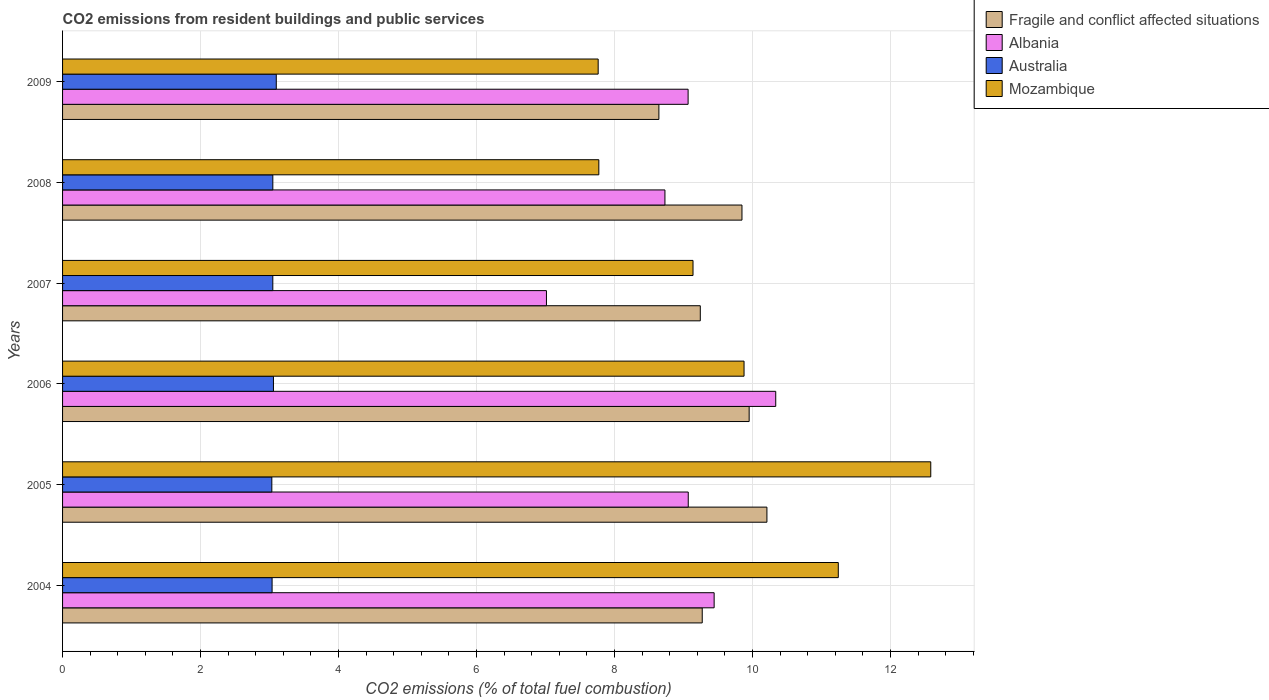How many groups of bars are there?
Keep it short and to the point. 6. How many bars are there on the 3rd tick from the top?
Offer a very short reply. 4. What is the total CO2 emitted in Fragile and conflict affected situations in 2009?
Provide a succinct answer. 8.64. Across all years, what is the maximum total CO2 emitted in Australia?
Your response must be concise. 3.1. Across all years, what is the minimum total CO2 emitted in Australia?
Offer a very short reply. 3.03. In which year was the total CO2 emitted in Mozambique maximum?
Offer a terse response. 2005. What is the total total CO2 emitted in Australia in the graph?
Give a very brief answer. 18.32. What is the difference between the total CO2 emitted in Mozambique in 2004 and that in 2005?
Provide a short and direct response. -1.34. What is the difference between the total CO2 emitted in Mozambique in 2004 and the total CO2 emitted in Fragile and conflict affected situations in 2007?
Ensure brevity in your answer.  2. What is the average total CO2 emitted in Fragile and conflict affected situations per year?
Your answer should be compact. 9.53. In the year 2008, what is the difference between the total CO2 emitted in Australia and total CO2 emitted in Fragile and conflict affected situations?
Provide a short and direct response. -6.8. What is the ratio of the total CO2 emitted in Albania in 2004 to that in 2005?
Offer a terse response. 1.04. Is the difference between the total CO2 emitted in Australia in 2008 and 2009 greater than the difference between the total CO2 emitted in Fragile and conflict affected situations in 2008 and 2009?
Provide a succinct answer. No. What is the difference between the highest and the second highest total CO2 emitted in Mozambique?
Offer a terse response. 1.34. What is the difference between the highest and the lowest total CO2 emitted in Australia?
Offer a terse response. 0.06. In how many years, is the total CO2 emitted in Mozambique greater than the average total CO2 emitted in Mozambique taken over all years?
Offer a very short reply. 3. Is the sum of the total CO2 emitted in Mozambique in 2004 and 2009 greater than the maximum total CO2 emitted in Australia across all years?
Provide a succinct answer. Yes. Is it the case that in every year, the sum of the total CO2 emitted in Albania and total CO2 emitted in Mozambique is greater than the sum of total CO2 emitted in Australia and total CO2 emitted in Fragile and conflict affected situations?
Your response must be concise. No. What does the 2nd bar from the top in 2004 represents?
Offer a terse response. Australia. Is it the case that in every year, the sum of the total CO2 emitted in Australia and total CO2 emitted in Mozambique is greater than the total CO2 emitted in Albania?
Offer a terse response. Yes. How many years are there in the graph?
Offer a terse response. 6. What is the difference between two consecutive major ticks on the X-axis?
Give a very brief answer. 2. Are the values on the major ticks of X-axis written in scientific E-notation?
Give a very brief answer. No. Does the graph contain any zero values?
Keep it short and to the point. No. Does the graph contain grids?
Offer a terse response. Yes. Where does the legend appear in the graph?
Provide a succinct answer. Top right. What is the title of the graph?
Provide a short and direct response. CO2 emissions from resident buildings and public services. Does "Iraq" appear as one of the legend labels in the graph?
Your response must be concise. No. What is the label or title of the X-axis?
Your answer should be very brief. CO2 emissions (% of total fuel combustion). What is the label or title of the Y-axis?
Keep it short and to the point. Years. What is the CO2 emissions (% of total fuel combustion) in Fragile and conflict affected situations in 2004?
Give a very brief answer. 9.27. What is the CO2 emissions (% of total fuel combustion) of Albania in 2004?
Make the answer very short. 9.44. What is the CO2 emissions (% of total fuel combustion) in Australia in 2004?
Ensure brevity in your answer.  3.04. What is the CO2 emissions (% of total fuel combustion) in Mozambique in 2004?
Your answer should be compact. 11.24. What is the CO2 emissions (% of total fuel combustion) in Fragile and conflict affected situations in 2005?
Ensure brevity in your answer.  10.21. What is the CO2 emissions (% of total fuel combustion) of Albania in 2005?
Give a very brief answer. 9.07. What is the CO2 emissions (% of total fuel combustion) in Australia in 2005?
Make the answer very short. 3.03. What is the CO2 emissions (% of total fuel combustion) of Mozambique in 2005?
Provide a succinct answer. 12.58. What is the CO2 emissions (% of total fuel combustion) in Fragile and conflict affected situations in 2006?
Offer a very short reply. 9.95. What is the CO2 emissions (% of total fuel combustion) of Albania in 2006?
Offer a very short reply. 10.34. What is the CO2 emissions (% of total fuel combustion) in Australia in 2006?
Your response must be concise. 3.06. What is the CO2 emissions (% of total fuel combustion) of Mozambique in 2006?
Your response must be concise. 9.88. What is the CO2 emissions (% of total fuel combustion) of Fragile and conflict affected situations in 2007?
Give a very brief answer. 9.24. What is the CO2 emissions (% of total fuel combustion) in Albania in 2007?
Your response must be concise. 7.01. What is the CO2 emissions (% of total fuel combustion) of Australia in 2007?
Give a very brief answer. 3.05. What is the CO2 emissions (% of total fuel combustion) of Mozambique in 2007?
Provide a short and direct response. 9.14. What is the CO2 emissions (% of total fuel combustion) of Fragile and conflict affected situations in 2008?
Provide a succinct answer. 9.85. What is the CO2 emissions (% of total fuel combustion) of Albania in 2008?
Keep it short and to the point. 8.73. What is the CO2 emissions (% of total fuel combustion) of Australia in 2008?
Provide a short and direct response. 3.05. What is the CO2 emissions (% of total fuel combustion) of Mozambique in 2008?
Your response must be concise. 7.77. What is the CO2 emissions (% of total fuel combustion) in Fragile and conflict affected situations in 2009?
Make the answer very short. 8.64. What is the CO2 emissions (% of total fuel combustion) of Albania in 2009?
Keep it short and to the point. 9.07. What is the CO2 emissions (% of total fuel combustion) of Australia in 2009?
Offer a terse response. 3.1. What is the CO2 emissions (% of total fuel combustion) of Mozambique in 2009?
Provide a succinct answer. 7.76. Across all years, what is the maximum CO2 emissions (% of total fuel combustion) of Fragile and conflict affected situations?
Make the answer very short. 10.21. Across all years, what is the maximum CO2 emissions (% of total fuel combustion) of Albania?
Give a very brief answer. 10.34. Across all years, what is the maximum CO2 emissions (% of total fuel combustion) of Australia?
Your answer should be compact. 3.1. Across all years, what is the maximum CO2 emissions (% of total fuel combustion) of Mozambique?
Provide a succinct answer. 12.58. Across all years, what is the minimum CO2 emissions (% of total fuel combustion) of Fragile and conflict affected situations?
Offer a terse response. 8.64. Across all years, what is the minimum CO2 emissions (% of total fuel combustion) of Albania?
Ensure brevity in your answer.  7.01. Across all years, what is the minimum CO2 emissions (% of total fuel combustion) in Australia?
Your answer should be compact. 3.03. Across all years, what is the minimum CO2 emissions (% of total fuel combustion) in Mozambique?
Your answer should be compact. 7.76. What is the total CO2 emissions (% of total fuel combustion) of Fragile and conflict affected situations in the graph?
Your answer should be very brief. 57.16. What is the total CO2 emissions (% of total fuel combustion) in Albania in the graph?
Your response must be concise. 53.66. What is the total CO2 emissions (% of total fuel combustion) in Australia in the graph?
Your answer should be compact. 18.32. What is the total CO2 emissions (% of total fuel combustion) of Mozambique in the graph?
Give a very brief answer. 58.37. What is the difference between the CO2 emissions (% of total fuel combustion) in Fragile and conflict affected situations in 2004 and that in 2005?
Your response must be concise. -0.94. What is the difference between the CO2 emissions (% of total fuel combustion) of Albania in 2004 and that in 2005?
Provide a short and direct response. 0.38. What is the difference between the CO2 emissions (% of total fuel combustion) in Australia in 2004 and that in 2005?
Provide a short and direct response. 0. What is the difference between the CO2 emissions (% of total fuel combustion) in Mozambique in 2004 and that in 2005?
Keep it short and to the point. -1.34. What is the difference between the CO2 emissions (% of total fuel combustion) of Fragile and conflict affected situations in 2004 and that in 2006?
Provide a short and direct response. -0.68. What is the difference between the CO2 emissions (% of total fuel combustion) of Albania in 2004 and that in 2006?
Give a very brief answer. -0.89. What is the difference between the CO2 emissions (% of total fuel combustion) of Australia in 2004 and that in 2006?
Give a very brief answer. -0.02. What is the difference between the CO2 emissions (% of total fuel combustion) of Mozambique in 2004 and that in 2006?
Offer a very short reply. 1.37. What is the difference between the CO2 emissions (% of total fuel combustion) in Fragile and conflict affected situations in 2004 and that in 2007?
Give a very brief answer. 0.03. What is the difference between the CO2 emissions (% of total fuel combustion) of Albania in 2004 and that in 2007?
Your answer should be compact. 2.43. What is the difference between the CO2 emissions (% of total fuel combustion) in Australia in 2004 and that in 2007?
Offer a very short reply. -0.01. What is the difference between the CO2 emissions (% of total fuel combustion) of Mozambique in 2004 and that in 2007?
Ensure brevity in your answer.  2.11. What is the difference between the CO2 emissions (% of total fuel combustion) in Fragile and conflict affected situations in 2004 and that in 2008?
Ensure brevity in your answer.  -0.58. What is the difference between the CO2 emissions (% of total fuel combustion) in Albania in 2004 and that in 2008?
Make the answer very short. 0.71. What is the difference between the CO2 emissions (% of total fuel combustion) of Australia in 2004 and that in 2008?
Offer a terse response. -0.01. What is the difference between the CO2 emissions (% of total fuel combustion) in Mozambique in 2004 and that in 2008?
Offer a terse response. 3.47. What is the difference between the CO2 emissions (% of total fuel combustion) in Fragile and conflict affected situations in 2004 and that in 2009?
Ensure brevity in your answer.  0.63. What is the difference between the CO2 emissions (% of total fuel combustion) in Albania in 2004 and that in 2009?
Provide a short and direct response. 0.38. What is the difference between the CO2 emissions (% of total fuel combustion) of Australia in 2004 and that in 2009?
Offer a very short reply. -0.06. What is the difference between the CO2 emissions (% of total fuel combustion) in Mozambique in 2004 and that in 2009?
Give a very brief answer. 3.48. What is the difference between the CO2 emissions (% of total fuel combustion) of Fragile and conflict affected situations in 2005 and that in 2006?
Provide a succinct answer. 0.26. What is the difference between the CO2 emissions (% of total fuel combustion) in Albania in 2005 and that in 2006?
Make the answer very short. -1.27. What is the difference between the CO2 emissions (% of total fuel combustion) in Australia in 2005 and that in 2006?
Provide a short and direct response. -0.02. What is the difference between the CO2 emissions (% of total fuel combustion) of Mozambique in 2005 and that in 2006?
Your answer should be very brief. 2.71. What is the difference between the CO2 emissions (% of total fuel combustion) in Fragile and conflict affected situations in 2005 and that in 2007?
Provide a short and direct response. 0.97. What is the difference between the CO2 emissions (% of total fuel combustion) in Albania in 2005 and that in 2007?
Keep it short and to the point. 2.06. What is the difference between the CO2 emissions (% of total fuel combustion) in Australia in 2005 and that in 2007?
Your response must be concise. -0.01. What is the difference between the CO2 emissions (% of total fuel combustion) in Mozambique in 2005 and that in 2007?
Your answer should be compact. 3.45. What is the difference between the CO2 emissions (% of total fuel combustion) of Fragile and conflict affected situations in 2005 and that in 2008?
Offer a terse response. 0.36. What is the difference between the CO2 emissions (% of total fuel combustion) of Albania in 2005 and that in 2008?
Offer a very short reply. 0.34. What is the difference between the CO2 emissions (% of total fuel combustion) in Australia in 2005 and that in 2008?
Your answer should be compact. -0.01. What is the difference between the CO2 emissions (% of total fuel combustion) in Mozambique in 2005 and that in 2008?
Your response must be concise. 4.81. What is the difference between the CO2 emissions (% of total fuel combustion) in Fragile and conflict affected situations in 2005 and that in 2009?
Offer a very short reply. 1.57. What is the difference between the CO2 emissions (% of total fuel combustion) of Albania in 2005 and that in 2009?
Offer a terse response. 0. What is the difference between the CO2 emissions (% of total fuel combustion) in Australia in 2005 and that in 2009?
Offer a very short reply. -0.06. What is the difference between the CO2 emissions (% of total fuel combustion) of Mozambique in 2005 and that in 2009?
Ensure brevity in your answer.  4.82. What is the difference between the CO2 emissions (% of total fuel combustion) in Fragile and conflict affected situations in 2006 and that in 2007?
Keep it short and to the point. 0.71. What is the difference between the CO2 emissions (% of total fuel combustion) of Albania in 2006 and that in 2007?
Offer a terse response. 3.32. What is the difference between the CO2 emissions (% of total fuel combustion) in Australia in 2006 and that in 2007?
Provide a succinct answer. 0.01. What is the difference between the CO2 emissions (% of total fuel combustion) in Mozambique in 2006 and that in 2007?
Keep it short and to the point. 0.74. What is the difference between the CO2 emissions (% of total fuel combustion) of Fragile and conflict affected situations in 2006 and that in 2008?
Keep it short and to the point. 0.1. What is the difference between the CO2 emissions (% of total fuel combustion) of Albania in 2006 and that in 2008?
Your answer should be compact. 1.61. What is the difference between the CO2 emissions (% of total fuel combustion) in Australia in 2006 and that in 2008?
Ensure brevity in your answer.  0.01. What is the difference between the CO2 emissions (% of total fuel combustion) of Mozambique in 2006 and that in 2008?
Make the answer very short. 2.1. What is the difference between the CO2 emissions (% of total fuel combustion) of Fragile and conflict affected situations in 2006 and that in 2009?
Offer a terse response. 1.31. What is the difference between the CO2 emissions (% of total fuel combustion) in Albania in 2006 and that in 2009?
Provide a short and direct response. 1.27. What is the difference between the CO2 emissions (% of total fuel combustion) of Australia in 2006 and that in 2009?
Your answer should be compact. -0.04. What is the difference between the CO2 emissions (% of total fuel combustion) in Mozambique in 2006 and that in 2009?
Offer a terse response. 2.11. What is the difference between the CO2 emissions (% of total fuel combustion) of Fragile and conflict affected situations in 2007 and that in 2008?
Your response must be concise. -0.6. What is the difference between the CO2 emissions (% of total fuel combustion) in Albania in 2007 and that in 2008?
Ensure brevity in your answer.  -1.72. What is the difference between the CO2 emissions (% of total fuel combustion) of Australia in 2007 and that in 2008?
Ensure brevity in your answer.  -0. What is the difference between the CO2 emissions (% of total fuel combustion) in Mozambique in 2007 and that in 2008?
Your answer should be very brief. 1.36. What is the difference between the CO2 emissions (% of total fuel combustion) of Albania in 2007 and that in 2009?
Your response must be concise. -2.05. What is the difference between the CO2 emissions (% of total fuel combustion) of Australia in 2007 and that in 2009?
Offer a very short reply. -0.05. What is the difference between the CO2 emissions (% of total fuel combustion) of Mozambique in 2007 and that in 2009?
Provide a succinct answer. 1.37. What is the difference between the CO2 emissions (% of total fuel combustion) of Fragile and conflict affected situations in 2008 and that in 2009?
Offer a very short reply. 1.2. What is the difference between the CO2 emissions (% of total fuel combustion) of Albania in 2008 and that in 2009?
Provide a short and direct response. -0.34. What is the difference between the CO2 emissions (% of total fuel combustion) of Mozambique in 2008 and that in 2009?
Offer a terse response. 0.01. What is the difference between the CO2 emissions (% of total fuel combustion) in Fragile and conflict affected situations in 2004 and the CO2 emissions (% of total fuel combustion) in Albania in 2005?
Give a very brief answer. 0.2. What is the difference between the CO2 emissions (% of total fuel combustion) of Fragile and conflict affected situations in 2004 and the CO2 emissions (% of total fuel combustion) of Australia in 2005?
Provide a succinct answer. 6.24. What is the difference between the CO2 emissions (% of total fuel combustion) of Fragile and conflict affected situations in 2004 and the CO2 emissions (% of total fuel combustion) of Mozambique in 2005?
Keep it short and to the point. -3.31. What is the difference between the CO2 emissions (% of total fuel combustion) in Albania in 2004 and the CO2 emissions (% of total fuel combustion) in Australia in 2005?
Your answer should be very brief. 6.41. What is the difference between the CO2 emissions (% of total fuel combustion) of Albania in 2004 and the CO2 emissions (% of total fuel combustion) of Mozambique in 2005?
Give a very brief answer. -3.14. What is the difference between the CO2 emissions (% of total fuel combustion) in Australia in 2004 and the CO2 emissions (% of total fuel combustion) in Mozambique in 2005?
Provide a short and direct response. -9.55. What is the difference between the CO2 emissions (% of total fuel combustion) of Fragile and conflict affected situations in 2004 and the CO2 emissions (% of total fuel combustion) of Albania in 2006?
Offer a terse response. -1.07. What is the difference between the CO2 emissions (% of total fuel combustion) in Fragile and conflict affected situations in 2004 and the CO2 emissions (% of total fuel combustion) in Australia in 2006?
Provide a short and direct response. 6.21. What is the difference between the CO2 emissions (% of total fuel combustion) in Fragile and conflict affected situations in 2004 and the CO2 emissions (% of total fuel combustion) in Mozambique in 2006?
Your answer should be compact. -0.61. What is the difference between the CO2 emissions (% of total fuel combustion) of Albania in 2004 and the CO2 emissions (% of total fuel combustion) of Australia in 2006?
Provide a succinct answer. 6.39. What is the difference between the CO2 emissions (% of total fuel combustion) in Albania in 2004 and the CO2 emissions (% of total fuel combustion) in Mozambique in 2006?
Make the answer very short. -0.43. What is the difference between the CO2 emissions (% of total fuel combustion) of Australia in 2004 and the CO2 emissions (% of total fuel combustion) of Mozambique in 2006?
Keep it short and to the point. -6.84. What is the difference between the CO2 emissions (% of total fuel combustion) of Fragile and conflict affected situations in 2004 and the CO2 emissions (% of total fuel combustion) of Albania in 2007?
Provide a short and direct response. 2.26. What is the difference between the CO2 emissions (% of total fuel combustion) in Fragile and conflict affected situations in 2004 and the CO2 emissions (% of total fuel combustion) in Australia in 2007?
Your answer should be compact. 6.22. What is the difference between the CO2 emissions (% of total fuel combustion) in Fragile and conflict affected situations in 2004 and the CO2 emissions (% of total fuel combustion) in Mozambique in 2007?
Make the answer very short. 0.13. What is the difference between the CO2 emissions (% of total fuel combustion) of Albania in 2004 and the CO2 emissions (% of total fuel combustion) of Australia in 2007?
Offer a terse response. 6.4. What is the difference between the CO2 emissions (% of total fuel combustion) of Albania in 2004 and the CO2 emissions (% of total fuel combustion) of Mozambique in 2007?
Make the answer very short. 0.31. What is the difference between the CO2 emissions (% of total fuel combustion) of Australia in 2004 and the CO2 emissions (% of total fuel combustion) of Mozambique in 2007?
Give a very brief answer. -6.1. What is the difference between the CO2 emissions (% of total fuel combustion) in Fragile and conflict affected situations in 2004 and the CO2 emissions (% of total fuel combustion) in Albania in 2008?
Your answer should be very brief. 0.54. What is the difference between the CO2 emissions (% of total fuel combustion) in Fragile and conflict affected situations in 2004 and the CO2 emissions (% of total fuel combustion) in Australia in 2008?
Provide a short and direct response. 6.22. What is the difference between the CO2 emissions (% of total fuel combustion) in Fragile and conflict affected situations in 2004 and the CO2 emissions (% of total fuel combustion) in Mozambique in 2008?
Give a very brief answer. 1.5. What is the difference between the CO2 emissions (% of total fuel combustion) of Albania in 2004 and the CO2 emissions (% of total fuel combustion) of Australia in 2008?
Provide a succinct answer. 6.4. What is the difference between the CO2 emissions (% of total fuel combustion) in Albania in 2004 and the CO2 emissions (% of total fuel combustion) in Mozambique in 2008?
Make the answer very short. 1.67. What is the difference between the CO2 emissions (% of total fuel combustion) of Australia in 2004 and the CO2 emissions (% of total fuel combustion) of Mozambique in 2008?
Provide a succinct answer. -4.74. What is the difference between the CO2 emissions (% of total fuel combustion) in Fragile and conflict affected situations in 2004 and the CO2 emissions (% of total fuel combustion) in Albania in 2009?
Your answer should be compact. 0.2. What is the difference between the CO2 emissions (% of total fuel combustion) of Fragile and conflict affected situations in 2004 and the CO2 emissions (% of total fuel combustion) of Australia in 2009?
Make the answer very short. 6.17. What is the difference between the CO2 emissions (% of total fuel combustion) in Fragile and conflict affected situations in 2004 and the CO2 emissions (% of total fuel combustion) in Mozambique in 2009?
Give a very brief answer. 1.51. What is the difference between the CO2 emissions (% of total fuel combustion) in Albania in 2004 and the CO2 emissions (% of total fuel combustion) in Australia in 2009?
Make the answer very short. 6.35. What is the difference between the CO2 emissions (% of total fuel combustion) of Albania in 2004 and the CO2 emissions (% of total fuel combustion) of Mozambique in 2009?
Ensure brevity in your answer.  1.68. What is the difference between the CO2 emissions (% of total fuel combustion) in Australia in 2004 and the CO2 emissions (% of total fuel combustion) in Mozambique in 2009?
Offer a very short reply. -4.73. What is the difference between the CO2 emissions (% of total fuel combustion) of Fragile and conflict affected situations in 2005 and the CO2 emissions (% of total fuel combustion) of Albania in 2006?
Offer a terse response. -0.13. What is the difference between the CO2 emissions (% of total fuel combustion) of Fragile and conflict affected situations in 2005 and the CO2 emissions (% of total fuel combustion) of Australia in 2006?
Offer a terse response. 7.15. What is the difference between the CO2 emissions (% of total fuel combustion) of Fragile and conflict affected situations in 2005 and the CO2 emissions (% of total fuel combustion) of Mozambique in 2006?
Offer a terse response. 0.33. What is the difference between the CO2 emissions (% of total fuel combustion) in Albania in 2005 and the CO2 emissions (% of total fuel combustion) in Australia in 2006?
Your answer should be very brief. 6.01. What is the difference between the CO2 emissions (% of total fuel combustion) of Albania in 2005 and the CO2 emissions (% of total fuel combustion) of Mozambique in 2006?
Provide a short and direct response. -0.81. What is the difference between the CO2 emissions (% of total fuel combustion) in Australia in 2005 and the CO2 emissions (% of total fuel combustion) in Mozambique in 2006?
Your response must be concise. -6.84. What is the difference between the CO2 emissions (% of total fuel combustion) in Fragile and conflict affected situations in 2005 and the CO2 emissions (% of total fuel combustion) in Albania in 2007?
Ensure brevity in your answer.  3.2. What is the difference between the CO2 emissions (% of total fuel combustion) of Fragile and conflict affected situations in 2005 and the CO2 emissions (% of total fuel combustion) of Australia in 2007?
Offer a terse response. 7.16. What is the difference between the CO2 emissions (% of total fuel combustion) of Fragile and conflict affected situations in 2005 and the CO2 emissions (% of total fuel combustion) of Mozambique in 2007?
Your answer should be compact. 1.07. What is the difference between the CO2 emissions (% of total fuel combustion) in Albania in 2005 and the CO2 emissions (% of total fuel combustion) in Australia in 2007?
Ensure brevity in your answer.  6.02. What is the difference between the CO2 emissions (% of total fuel combustion) of Albania in 2005 and the CO2 emissions (% of total fuel combustion) of Mozambique in 2007?
Ensure brevity in your answer.  -0.07. What is the difference between the CO2 emissions (% of total fuel combustion) in Australia in 2005 and the CO2 emissions (% of total fuel combustion) in Mozambique in 2007?
Your answer should be compact. -6.1. What is the difference between the CO2 emissions (% of total fuel combustion) of Fragile and conflict affected situations in 2005 and the CO2 emissions (% of total fuel combustion) of Albania in 2008?
Keep it short and to the point. 1.48. What is the difference between the CO2 emissions (% of total fuel combustion) of Fragile and conflict affected situations in 2005 and the CO2 emissions (% of total fuel combustion) of Australia in 2008?
Your answer should be compact. 7.16. What is the difference between the CO2 emissions (% of total fuel combustion) in Fragile and conflict affected situations in 2005 and the CO2 emissions (% of total fuel combustion) in Mozambique in 2008?
Your answer should be very brief. 2.44. What is the difference between the CO2 emissions (% of total fuel combustion) of Albania in 2005 and the CO2 emissions (% of total fuel combustion) of Australia in 2008?
Your answer should be compact. 6.02. What is the difference between the CO2 emissions (% of total fuel combustion) of Albania in 2005 and the CO2 emissions (% of total fuel combustion) of Mozambique in 2008?
Make the answer very short. 1.3. What is the difference between the CO2 emissions (% of total fuel combustion) of Australia in 2005 and the CO2 emissions (% of total fuel combustion) of Mozambique in 2008?
Provide a short and direct response. -4.74. What is the difference between the CO2 emissions (% of total fuel combustion) of Fragile and conflict affected situations in 2005 and the CO2 emissions (% of total fuel combustion) of Albania in 2009?
Provide a short and direct response. 1.14. What is the difference between the CO2 emissions (% of total fuel combustion) of Fragile and conflict affected situations in 2005 and the CO2 emissions (% of total fuel combustion) of Australia in 2009?
Your response must be concise. 7.11. What is the difference between the CO2 emissions (% of total fuel combustion) in Fragile and conflict affected situations in 2005 and the CO2 emissions (% of total fuel combustion) in Mozambique in 2009?
Make the answer very short. 2.45. What is the difference between the CO2 emissions (% of total fuel combustion) of Albania in 2005 and the CO2 emissions (% of total fuel combustion) of Australia in 2009?
Give a very brief answer. 5.97. What is the difference between the CO2 emissions (% of total fuel combustion) in Albania in 2005 and the CO2 emissions (% of total fuel combustion) in Mozambique in 2009?
Give a very brief answer. 1.31. What is the difference between the CO2 emissions (% of total fuel combustion) in Australia in 2005 and the CO2 emissions (% of total fuel combustion) in Mozambique in 2009?
Offer a terse response. -4.73. What is the difference between the CO2 emissions (% of total fuel combustion) of Fragile and conflict affected situations in 2006 and the CO2 emissions (% of total fuel combustion) of Albania in 2007?
Give a very brief answer. 2.94. What is the difference between the CO2 emissions (% of total fuel combustion) of Fragile and conflict affected situations in 2006 and the CO2 emissions (% of total fuel combustion) of Australia in 2007?
Your answer should be compact. 6.9. What is the difference between the CO2 emissions (% of total fuel combustion) in Fragile and conflict affected situations in 2006 and the CO2 emissions (% of total fuel combustion) in Mozambique in 2007?
Offer a very short reply. 0.81. What is the difference between the CO2 emissions (% of total fuel combustion) in Albania in 2006 and the CO2 emissions (% of total fuel combustion) in Australia in 2007?
Keep it short and to the point. 7.29. What is the difference between the CO2 emissions (% of total fuel combustion) of Albania in 2006 and the CO2 emissions (% of total fuel combustion) of Mozambique in 2007?
Keep it short and to the point. 1.2. What is the difference between the CO2 emissions (% of total fuel combustion) of Australia in 2006 and the CO2 emissions (% of total fuel combustion) of Mozambique in 2007?
Make the answer very short. -6.08. What is the difference between the CO2 emissions (% of total fuel combustion) in Fragile and conflict affected situations in 2006 and the CO2 emissions (% of total fuel combustion) in Albania in 2008?
Ensure brevity in your answer.  1.22. What is the difference between the CO2 emissions (% of total fuel combustion) of Fragile and conflict affected situations in 2006 and the CO2 emissions (% of total fuel combustion) of Australia in 2008?
Make the answer very short. 6.9. What is the difference between the CO2 emissions (% of total fuel combustion) of Fragile and conflict affected situations in 2006 and the CO2 emissions (% of total fuel combustion) of Mozambique in 2008?
Offer a very short reply. 2.18. What is the difference between the CO2 emissions (% of total fuel combustion) in Albania in 2006 and the CO2 emissions (% of total fuel combustion) in Australia in 2008?
Keep it short and to the point. 7.29. What is the difference between the CO2 emissions (% of total fuel combustion) in Albania in 2006 and the CO2 emissions (% of total fuel combustion) in Mozambique in 2008?
Keep it short and to the point. 2.56. What is the difference between the CO2 emissions (% of total fuel combustion) of Australia in 2006 and the CO2 emissions (% of total fuel combustion) of Mozambique in 2008?
Provide a succinct answer. -4.72. What is the difference between the CO2 emissions (% of total fuel combustion) in Fragile and conflict affected situations in 2006 and the CO2 emissions (% of total fuel combustion) in Albania in 2009?
Provide a succinct answer. 0.88. What is the difference between the CO2 emissions (% of total fuel combustion) of Fragile and conflict affected situations in 2006 and the CO2 emissions (% of total fuel combustion) of Australia in 2009?
Your response must be concise. 6.85. What is the difference between the CO2 emissions (% of total fuel combustion) in Fragile and conflict affected situations in 2006 and the CO2 emissions (% of total fuel combustion) in Mozambique in 2009?
Give a very brief answer. 2.19. What is the difference between the CO2 emissions (% of total fuel combustion) in Albania in 2006 and the CO2 emissions (% of total fuel combustion) in Australia in 2009?
Provide a short and direct response. 7.24. What is the difference between the CO2 emissions (% of total fuel combustion) of Albania in 2006 and the CO2 emissions (% of total fuel combustion) of Mozambique in 2009?
Your answer should be very brief. 2.57. What is the difference between the CO2 emissions (% of total fuel combustion) in Australia in 2006 and the CO2 emissions (% of total fuel combustion) in Mozambique in 2009?
Your answer should be very brief. -4.71. What is the difference between the CO2 emissions (% of total fuel combustion) in Fragile and conflict affected situations in 2007 and the CO2 emissions (% of total fuel combustion) in Albania in 2008?
Provide a short and direct response. 0.51. What is the difference between the CO2 emissions (% of total fuel combustion) of Fragile and conflict affected situations in 2007 and the CO2 emissions (% of total fuel combustion) of Australia in 2008?
Your answer should be compact. 6.2. What is the difference between the CO2 emissions (% of total fuel combustion) in Fragile and conflict affected situations in 2007 and the CO2 emissions (% of total fuel combustion) in Mozambique in 2008?
Provide a succinct answer. 1.47. What is the difference between the CO2 emissions (% of total fuel combustion) in Albania in 2007 and the CO2 emissions (% of total fuel combustion) in Australia in 2008?
Make the answer very short. 3.97. What is the difference between the CO2 emissions (% of total fuel combustion) of Albania in 2007 and the CO2 emissions (% of total fuel combustion) of Mozambique in 2008?
Your answer should be compact. -0.76. What is the difference between the CO2 emissions (% of total fuel combustion) of Australia in 2007 and the CO2 emissions (% of total fuel combustion) of Mozambique in 2008?
Your answer should be very brief. -4.72. What is the difference between the CO2 emissions (% of total fuel combustion) in Fragile and conflict affected situations in 2007 and the CO2 emissions (% of total fuel combustion) in Albania in 2009?
Provide a short and direct response. 0.18. What is the difference between the CO2 emissions (% of total fuel combustion) in Fragile and conflict affected situations in 2007 and the CO2 emissions (% of total fuel combustion) in Australia in 2009?
Make the answer very short. 6.15. What is the difference between the CO2 emissions (% of total fuel combustion) in Fragile and conflict affected situations in 2007 and the CO2 emissions (% of total fuel combustion) in Mozambique in 2009?
Offer a very short reply. 1.48. What is the difference between the CO2 emissions (% of total fuel combustion) of Albania in 2007 and the CO2 emissions (% of total fuel combustion) of Australia in 2009?
Offer a terse response. 3.92. What is the difference between the CO2 emissions (% of total fuel combustion) in Albania in 2007 and the CO2 emissions (% of total fuel combustion) in Mozambique in 2009?
Your answer should be very brief. -0.75. What is the difference between the CO2 emissions (% of total fuel combustion) in Australia in 2007 and the CO2 emissions (% of total fuel combustion) in Mozambique in 2009?
Ensure brevity in your answer.  -4.72. What is the difference between the CO2 emissions (% of total fuel combustion) in Fragile and conflict affected situations in 2008 and the CO2 emissions (% of total fuel combustion) in Albania in 2009?
Give a very brief answer. 0.78. What is the difference between the CO2 emissions (% of total fuel combustion) of Fragile and conflict affected situations in 2008 and the CO2 emissions (% of total fuel combustion) of Australia in 2009?
Make the answer very short. 6.75. What is the difference between the CO2 emissions (% of total fuel combustion) in Fragile and conflict affected situations in 2008 and the CO2 emissions (% of total fuel combustion) in Mozambique in 2009?
Keep it short and to the point. 2.08. What is the difference between the CO2 emissions (% of total fuel combustion) in Albania in 2008 and the CO2 emissions (% of total fuel combustion) in Australia in 2009?
Ensure brevity in your answer.  5.63. What is the difference between the CO2 emissions (% of total fuel combustion) in Albania in 2008 and the CO2 emissions (% of total fuel combustion) in Mozambique in 2009?
Your response must be concise. 0.97. What is the difference between the CO2 emissions (% of total fuel combustion) of Australia in 2008 and the CO2 emissions (% of total fuel combustion) of Mozambique in 2009?
Keep it short and to the point. -4.72. What is the average CO2 emissions (% of total fuel combustion) of Fragile and conflict affected situations per year?
Your response must be concise. 9.53. What is the average CO2 emissions (% of total fuel combustion) in Albania per year?
Offer a very short reply. 8.94. What is the average CO2 emissions (% of total fuel combustion) of Australia per year?
Make the answer very short. 3.05. What is the average CO2 emissions (% of total fuel combustion) in Mozambique per year?
Your answer should be compact. 9.73. In the year 2004, what is the difference between the CO2 emissions (% of total fuel combustion) in Fragile and conflict affected situations and CO2 emissions (% of total fuel combustion) in Albania?
Make the answer very short. -0.17. In the year 2004, what is the difference between the CO2 emissions (% of total fuel combustion) in Fragile and conflict affected situations and CO2 emissions (% of total fuel combustion) in Australia?
Your answer should be very brief. 6.23. In the year 2004, what is the difference between the CO2 emissions (% of total fuel combustion) of Fragile and conflict affected situations and CO2 emissions (% of total fuel combustion) of Mozambique?
Provide a succinct answer. -1.97. In the year 2004, what is the difference between the CO2 emissions (% of total fuel combustion) of Albania and CO2 emissions (% of total fuel combustion) of Australia?
Your response must be concise. 6.41. In the year 2004, what is the difference between the CO2 emissions (% of total fuel combustion) in Albania and CO2 emissions (% of total fuel combustion) in Mozambique?
Ensure brevity in your answer.  -1.8. In the year 2004, what is the difference between the CO2 emissions (% of total fuel combustion) of Australia and CO2 emissions (% of total fuel combustion) of Mozambique?
Give a very brief answer. -8.21. In the year 2005, what is the difference between the CO2 emissions (% of total fuel combustion) in Fragile and conflict affected situations and CO2 emissions (% of total fuel combustion) in Albania?
Offer a terse response. 1.14. In the year 2005, what is the difference between the CO2 emissions (% of total fuel combustion) of Fragile and conflict affected situations and CO2 emissions (% of total fuel combustion) of Australia?
Ensure brevity in your answer.  7.18. In the year 2005, what is the difference between the CO2 emissions (% of total fuel combustion) in Fragile and conflict affected situations and CO2 emissions (% of total fuel combustion) in Mozambique?
Provide a succinct answer. -2.37. In the year 2005, what is the difference between the CO2 emissions (% of total fuel combustion) in Albania and CO2 emissions (% of total fuel combustion) in Australia?
Ensure brevity in your answer.  6.04. In the year 2005, what is the difference between the CO2 emissions (% of total fuel combustion) of Albania and CO2 emissions (% of total fuel combustion) of Mozambique?
Keep it short and to the point. -3.51. In the year 2005, what is the difference between the CO2 emissions (% of total fuel combustion) in Australia and CO2 emissions (% of total fuel combustion) in Mozambique?
Make the answer very short. -9.55. In the year 2006, what is the difference between the CO2 emissions (% of total fuel combustion) in Fragile and conflict affected situations and CO2 emissions (% of total fuel combustion) in Albania?
Your answer should be very brief. -0.39. In the year 2006, what is the difference between the CO2 emissions (% of total fuel combustion) of Fragile and conflict affected situations and CO2 emissions (% of total fuel combustion) of Australia?
Your answer should be compact. 6.89. In the year 2006, what is the difference between the CO2 emissions (% of total fuel combustion) of Fragile and conflict affected situations and CO2 emissions (% of total fuel combustion) of Mozambique?
Your response must be concise. 0.07. In the year 2006, what is the difference between the CO2 emissions (% of total fuel combustion) in Albania and CO2 emissions (% of total fuel combustion) in Australia?
Keep it short and to the point. 7.28. In the year 2006, what is the difference between the CO2 emissions (% of total fuel combustion) of Albania and CO2 emissions (% of total fuel combustion) of Mozambique?
Your response must be concise. 0.46. In the year 2006, what is the difference between the CO2 emissions (% of total fuel combustion) of Australia and CO2 emissions (% of total fuel combustion) of Mozambique?
Your response must be concise. -6.82. In the year 2007, what is the difference between the CO2 emissions (% of total fuel combustion) in Fragile and conflict affected situations and CO2 emissions (% of total fuel combustion) in Albania?
Your answer should be very brief. 2.23. In the year 2007, what is the difference between the CO2 emissions (% of total fuel combustion) of Fragile and conflict affected situations and CO2 emissions (% of total fuel combustion) of Australia?
Your answer should be very brief. 6.2. In the year 2007, what is the difference between the CO2 emissions (% of total fuel combustion) in Fragile and conflict affected situations and CO2 emissions (% of total fuel combustion) in Mozambique?
Provide a short and direct response. 0.11. In the year 2007, what is the difference between the CO2 emissions (% of total fuel combustion) of Albania and CO2 emissions (% of total fuel combustion) of Australia?
Keep it short and to the point. 3.97. In the year 2007, what is the difference between the CO2 emissions (% of total fuel combustion) of Albania and CO2 emissions (% of total fuel combustion) of Mozambique?
Your response must be concise. -2.12. In the year 2007, what is the difference between the CO2 emissions (% of total fuel combustion) in Australia and CO2 emissions (% of total fuel combustion) in Mozambique?
Your answer should be compact. -6.09. In the year 2008, what is the difference between the CO2 emissions (% of total fuel combustion) of Fragile and conflict affected situations and CO2 emissions (% of total fuel combustion) of Albania?
Make the answer very short. 1.12. In the year 2008, what is the difference between the CO2 emissions (% of total fuel combustion) in Fragile and conflict affected situations and CO2 emissions (% of total fuel combustion) in Australia?
Offer a terse response. 6.8. In the year 2008, what is the difference between the CO2 emissions (% of total fuel combustion) in Fragile and conflict affected situations and CO2 emissions (% of total fuel combustion) in Mozambique?
Keep it short and to the point. 2.07. In the year 2008, what is the difference between the CO2 emissions (% of total fuel combustion) of Albania and CO2 emissions (% of total fuel combustion) of Australia?
Provide a succinct answer. 5.68. In the year 2008, what is the difference between the CO2 emissions (% of total fuel combustion) in Albania and CO2 emissions (% of total fuel combustion) in Mozambique?
Keep it short and to the point. 0.96. In the year 2008, what is the difference between the CO2 emissions (% of total fuel combustion) of Australia and CO2 emissions (% of total fuel combustion) of Mozambique?
Make the answer very short. -4.72. In the year 2009, what is the difference between the CO2 emissions (% of total fuel combustion) of Fragile and conflict affected situations and CO2 emissions (% of total fuel combustion) of Albania?
Keep it short and to the point. -0.42. In the year 2009, what is the difference between the CO2 emissions (% of total fuel combustion) of Fragile and conflict affected situations and CO2 emissions (% of total fuel combustion) of Australia?
Your answer should be compact. 5.55. In the year 2009, what is the difference between the CO2 emissions (% of total fuel combustion) in Fragile and conflict affected situations and CO2 emissions (% of total fuel combustion) in Mozambique?
Provide a succinct answer. 0.88. In the year 2009, what is the difference between the CO2 emissions (% of total fuel combustion) in Albania and CO2 emissions (% of total fuel combustion) in Australia?
Your answer should be very brief. 5.97. In the year 2009, what is the difference between the CO2 emissions (% of total fuel combustion) in Albania and CO2 emissions (% of total fuel combustion) in Mozambique?
Provide a succinct answer. 1.3. In the year 2009, what is the difference between the CO2 emissions (% of total fuel combustion) of Australia and CO2 emissions (% of total fuel combustion) of Mozambique?
Offer a terse response. -4.67. What is the ratio of the CO2 emissions (% of total fuel combustion) in Fragile and conflict affected situations in 2004 to that in 2005?
Your answer should be very brief. 0.91. What is the ratio of the CO2 emissions (% of total fuel combustion) of Albania in 2004 to that in 2005?
Offer a very short reply. 1.04. What is the ratio of the CO2 emissions (% of total fuel combustion) of Mozambique in 2004 to that in 2005?
Ensure brevity in your answer.  0.89. What is the ratio of the CO2 emissions (% of total fuel combustion) of Fragile and conflict affected situations in 2004 to that in 2006?
Your response must be concise. 0.93. What is the ratio of the CO2 emissions (% of total fuel combustion) in Albania in 2004 to that in 2006?
Your answer should be very brief. 0.91. What is the ratio of the CO2 emissions (% of total fuel combustion) of Australia in 2004 to that in 2006?
Offer a very short reply. 0.99. What is the ratio of the CO2 emissions (% of total fuel combustion) of Mozambique in 2004 to that in 2006?
Offer a terse response. 1.14. What is the ratio of the CO2 emissions (% of total fuel combustion) of Fragile and conflict affected situations in 2004 to that in 2007?
Make the answer very short. 1. What is the ratio of the CO2 emissions (% of total fuel combustion) in Albania in 2004 to that in 2007?
Give a very brief answer. 1.35. What is the ratio of the CO2 emissions (% of total fuel combustion) of Mozambique in 2004 to that in 2007?
Offer a terse response. 1.23. What is the ratio of the CO2 emissions (% of total fuel combustion) in Fragile and conflict affected situations in 2004 to that in 2008?
Ensure brevity in your answer.  0.94. What is the ratio of the CO2 emissions (% of total fuel combustion) in Albania in 2004 to that in 2008?
Your answer should be compact. 1.08. What is the ratio of the CO2 emissions (% of total fuel combustion) in Australia in 2004 to that in 2008?
Your answer should be compact. 1. What is the ratio of the CO2 emissions (% of total fuel combustion) of Mozambique in 2004 to that in 2008?
Offer a very short reply. 1.45. What is the ratio of the CO2 emissions (% of total fuel combustion) in Fragile and conflict affected situations in 2004 to that in 2009?
Give a very brief answer. 1.07. What is the ratio of the CO2 emissions (% of total fuel combustion) of Albania in 2004 to that in 2009?
Your response must be concise. 1.04. What is the ratio of the CO2 emissions (% of total fuel combustion) in Australia in 2004 to that in 2009?
Your answer should be compact. 0.98. What is the ratio of the CO2 emissions (% of total fuel combustion) in Mozambique in 2004 to that in 2009?
Ensure brevity in your answer.  1.45. What is the ratio of the CO2 emissions (% of total fuel combustion) of Fragile and conflict affected situations in 2005 to that in 2006?
Ensure brevity in your answer.  1.03. What is the ratio of the CO2 emissions (% of total fuel combustion) in Albania in 2005 to that in 2006?
Your answer should be very brief. 0.88. What is the ratio of the CO2 emissions (% of total fuel combustion) in Mozambique in 2005 to that in 2006?
Provide a short and direct response. 1.27. What is the ratio of the CO2 emissions (% of total fuel combustion) in Fragile and conflict affected situations in 2005 to that in 2007?
Your response must be concise. 1.1. What is the ratio of the CO2 emissions (% of total fuel combustion) of Albania in 2005 to that in 2007?
Provide a succinct answer. 1.29. What is the ratio of the CO2 emissions (% of total fuel combustion) in Mozambique in 2005 to that in 2007?
Your response must be concise. 1.38. What is the ratio of the CO2 emissions (% of total fuel combustion) in Fragile and conflict affected situations in 2005 to that in 2008?
Your response must be concise. 1.04. What is the ratio of the CO2 emissions (% of total fuel combustion) of Albania in 2005 to that in 2008?
Your answer should be very brief. 1.04. What is the ratio of the CO2 emissions (% of total fuel combustion) of Australia in 2005 to that in 2008?
Your answer should be compact. 1. What is the ratio of the CO2 emissions (% of total fuel combustion) in Mozambique in 2005 to that in 2008?
Ensure brevity in your answer.  1.62. What is the ratio of the CO2 emissions (% of total fuel combustion) of Fragile and conflict affected situations in 2005 to that in 2009?
Your response must be concise. 1.18. What is the ratio of the CO2 emissions (% of total fuel combustion) of Australia in 2005 to that in 2009?
Offer a terse response. 0.98. What is the ratio of the CO2 emissions (% of total fuel combustion) of Mozambique in 2005 to that in 2009?
Offer a terse response. 1.62. What is the ratio of the CO2 emissions (% of total fuel combustion) of Fragile and conflict affected situations in 2006 to that in 2007?
Keep it short and to the point. 1.08. What is the ratio of the CO2 emissions (% of total fuel combustion) of Albania in 2006 to that in 2007?
Your answer should be very brief. 1.47. What is the ratio of the CO2 emissions (% of total fuel combustion) in Mozambique in 2006 to that in 2007?
Offer a very short reply. 1.08. What is the ratio of the CO2 emissions (% of total fuel combustion) in Fragile and conflict affected situations in 2006 to that in 2008?
Provide a succinct answer. 1.01. What is the ratio of the CO2 emissions (% of total fuel combustion) in Albania in 2006 to that in 2008?
Make the answer very short. 1.18. What is the ratio of the CO2 emissions (% of total fuel combustion) of Mozambique in 2006 to that in 2008?
Offer a terse response. 1.27. What is the ratio of the CO2 emissions (% of total fuel combustion) of Fragile and conflict affected situations in 2006 to that in 2009?
Your answer should be very brief. 1.15. What is the ratio of the CO2 emissions (% of total fuel combustion) of Albania in 2006 to that in 2009?
Offer a terse response. 1.14. What is the ratio of the CO2 emissions (% of total fuel combustion) of Australia in 2006 to that in 2009?
Offer a terse response. 0.99. What is the ratio of the CO2 emissions (% of total fuel combustion) in Mozambique in 2006 to that in 2009?
Offer a very short reply. 1.27. What is the ratio of the CO2 emissions (% of total fuel combustion) in Fragile and conflict affected situations in 2007 to that in 2008?
Offer a very short reply. 0.94. What is the ratio of the CO2 emissions (% of total fuel combustion) in Albania in 2007 to that in 2008?
Keep it short and to the point. 0.8. What is the ratio of the CO2 emissions (% of total fuel combustion) of Mozambique in 2007 to that in 2008?
Ensure brevity in your answer.  1.18. What is the ratio of the CO2 emissions (% of total fuel combustion) in Fragile and conflict affected situations in 2007 to that in 2009?
Provide a succinct answer. 1.07. What is the ratio of the CO2 emissions (% of total fuel combustion) in Albania in 2007 to that in 2009?
Your answer should be compact. 0.77. What is the ratio of the CO2 emissions (% of total fuel combustion) of Australia in 2007 to that in 2009?
Provide a succinct answer. 0.98. What is the ratio of the CO2 emissions (% of total fuel combustion) in Mozambique in 2007 to that in 2009?
Keep it short and to the point. 1.18. What is the ratio of the CO2 emissions (% of total fuel combustion) of Fragile and conflict affected situations in 2008 to that in 2009?
Provide a succinct answer. 1.14. What is the ratio of the CO2 emissions (% of total fuel combustion) of Albania in 2008 to that in 2009?
Your answer should be very brief. 0.96. What is the ratio of the CO2 emissions (% of total fuel combustion) in Australia in 2008 to that in 2009?
Provide a short and direct response. 0.98. What is the ratio of the CO2 emissions (% of total fuel combustion) of Mozambique in 2008 to that in 2009?
Provide a short and direct response. 1. What is the difference between the highest and the second highest CO2 emissions (% of total fuel combustion) in Fragile and conflict affected situations?
Give a very brief answer. 0.26. What is the difference between the highest and the second highest CO2 emissions (% of total fuel combustion) in Albania?
Offer a terse response. 0.89. What is the difference between the highest and the second highest CO2 emissions (% of total fuel combustion) of Australia?
Your response must be concise. 0.04. What is the difference between the highest and the second highest CO2 emissions (% of total fuel combustion) in Mozambique?
Your response must be concise. 1.34. What is the difference between the highest and the lowest CO2 emissions (% of total fuel combustion) of Fragile and conflict affected situations?
Make the answer very short. 1.57. What is the difference between the highest and the lowest CO2 emissions (% of total fuel combustion) of Albania?
Provide a succinct answer. 3.32. What is the difference between the highest and the lowest CO2 emissions (% of total fuel combustion) of Australia?
Make the answer very short. 0.06. What is the difference between the highest and the lowest CO2 emissions (% of total fuel combustion) of Mozambique?
Your answer should be very brief. 4.82. 